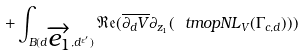Convert formula to latex. <formula><loc_0><loc_0><loc_500><loc_500>+ \int _ { B ( d \overrightarrow { e _ { 1 } } , d ^ { \varepsilon ^ { \prime } } ) } \mathfrak { R } \mathfrak { e } ( \overline { \partial _ { d } V } \partial _ { z _ { 1 } } ( \ t m o p { N L } _ { V } ( \Gamma _ { c , d } ) ) )</formula> 